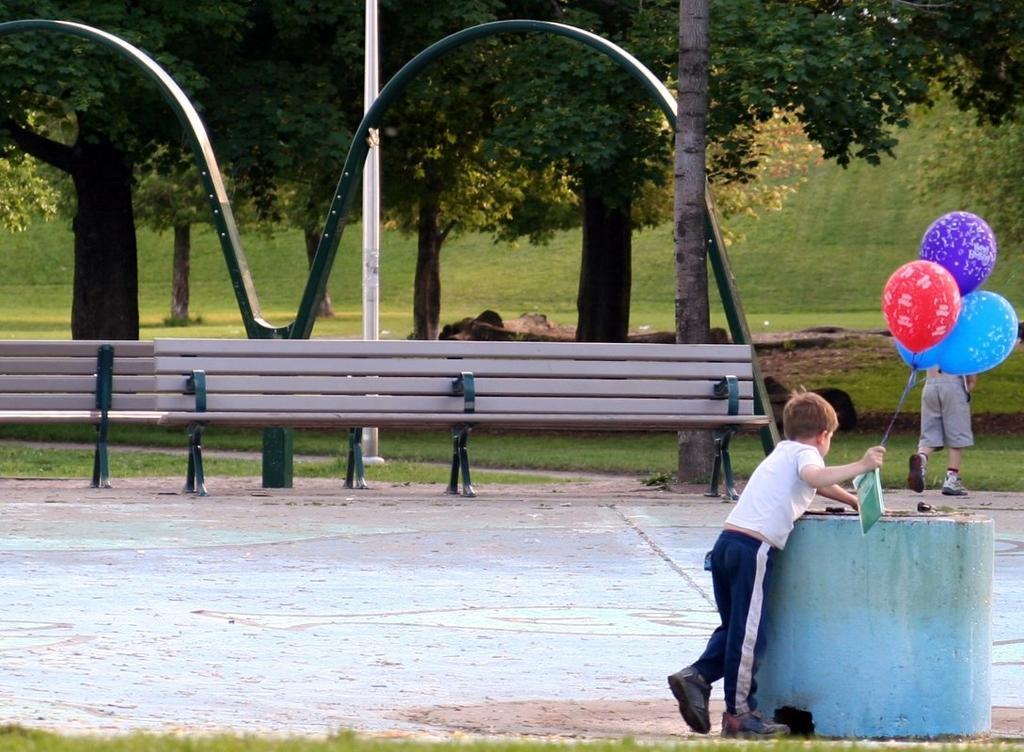In one or two sentences, can you explain what this image depicts? On the right side a boy is there, he wore t-shirt, trouser, shoes and also holding the balloons in his right hand. In the middle there are benches and trees. 